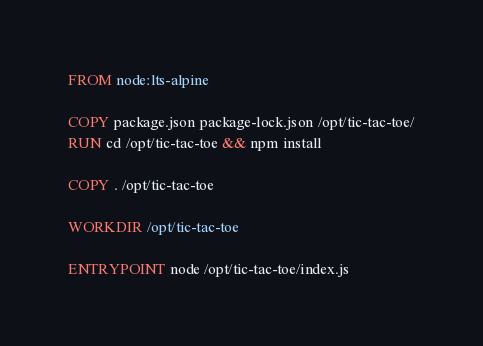Convert code to text. <code><loc_0><loc_0><loc_500><loc_500><_Dockerfile_>FROM node:lts-alpine

COPY package.json package-lock.json /opt/tic-tac-toe/
RUN cd /opt/tic-tac-toe && npm install

COPY . /opt/tic-tac-toe

WORKDIR /opt/tic-tac-toe

ENTRYPOINT node /opt/tic-tac-toe/index.js
</code> 